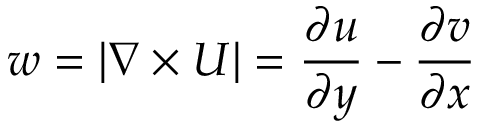Convert formula to latex. <formula><loc_0><loc_0><loc_500><loc_500>w = | \nabla \times U | = \frac { \partial u } { \partial y } - \frac { \partial v } { \partial x }</formula> 